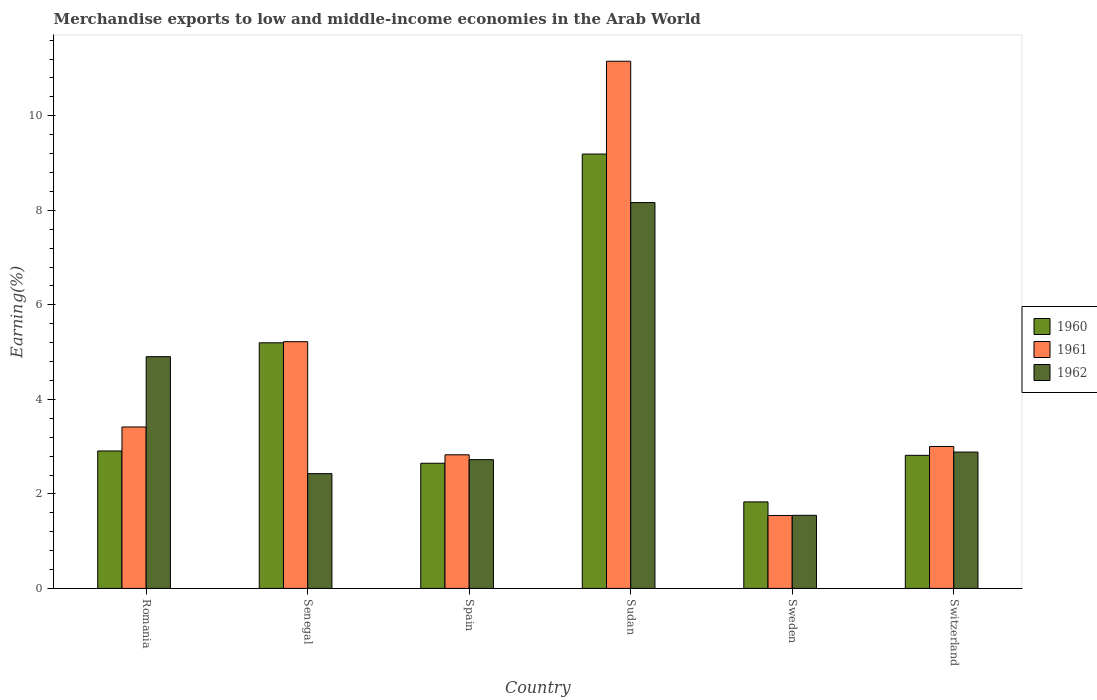Are the number of bars per tick equal to the number of legend labels?
Make the answer very short. Yes. Are the number of bars on each tick of the X-axis equal?
Your response must be concise. Yes. How many bars are there on the 3rd tick from the right?
Offer a terse response. 3. What is the label of the 6th group of bars from the left?
Provide a short and direct response. Switzerland. In how many cases, is the number of bars for a given country not equal to the number of legend labels?
Your answer should be compact. 0. What is the percentage of amount earned from merchandise exports in 1962 in Sudan?
Offer a terse response. 8.16. Across all countries, what is the maximum percentage of amount earned from merchandise exports in 1961?
Provide a short and direct response. 11.15. Across all countries, what is the minimum percentage of amount earned from merchandise exports in 1962?
Your answer should be compact. 1.55. In which country was the percentage of amount earned from merchandise exports in 1961 maximum?
Keep it short and to the point. Sudan. What is the total percentage of amount earned from merchandise exports in 1961 in the graph?
Your answer should be very brief. 27.17. What is the difference between the percentage of amount earned from merchandise exports in 1961 in Spain and that in Switzerland?
Offer a very short reply. -0.18. What is the difference between the percentage of amount earned from merchandise exports in 1962 in Sudan and the percentage of amount earned from merchandise exports in 1961 in Sweden?
Ensure brevity in your answer.  6.62. What is the average percentage of amount earned from merchandise exports in 1961 per country?
Offer a terse response. 4.53. What is the difference between the percentage of amount earned from merchandise exports of/in 1960 and percentage of amount earned from merchandise exports of/in 1962 in Sweden?
Give a very brief answer. 0.28. In how many countries, is the percentage of amount earned from merchandise exports in 1960 greater than 4.4 %?
Keep it short and to the point. 2. What is the ratio of the percentage of amount earned from merchandise exports in 1961 in Sweden to that in Switzerland?
Offer a terse response. 0.51. Is the percentage of amount earned from merchandise exports in 1961 in Senegal less than that in Sudan?
Give a very brief answer. Yes. What is the difference between the highest and the second highest percentage of amount earned from merchandise exports in 1961?
Your answer should be compact. -7.74. What is the difference between the highest and the lowest percentage of amount earned from merchandise exports in 1960?
Provide a succinct answer. 7.36. What does the 2nd bar from the left in Spain represents?
Offer a very short reply. 1961. How many bars are there?
Your answer should be compact. 18. How many countries are there in the graph?
Give a very brief answer. 6. What is the difference between two consecutive major ticks on the Y-axis?
Your answer should be very brief. 2. Does the graph contain any zero values?
Provide a succinct answer. No. Where does the legend appear in the graph?
Make the answer very short. Center right. What is the title of the graph?
Your answer should be compact. Merchandise exports to low and middle-income economies in the Arab World. What is the label or title of the X-axis?
Your answer should be very brief. Country. What is the label or title of the Y-axis?
Your response must be concise. Earning(%). What is the Earning(%) of 1960 in Romania?
Give a very brief answer. 2.91. What is the Earning(%) in 1961 in Romania?
Your answer should be compact. 3.42. What is the Earning(%) of 1962 in Romania?
Your response must be concise. 4.9. What is the Earning(%) of 1960 in Senegal?
Offer a terse response. 5.2. What is the Earning(%) of 1961 in Senegal?
Offer a very short reply. 5.22. What is the Earning(%) in 1962 in Senegal?
Give a very brief answer. 2.43. What is the Earning(%) in 1960 in Spain?
Ensure brevity in your answer.  2.65. What is the Earning(%) in 1961 in Spain?
Your answer should be compact. 2.83. What is the Earning(%) in 1962 in Spain?
Keep it short and to the point. 2.73. What is the Earning(%) in 1960 in Sudan?
Ensure brevity in your answer.  9.19. What is the Earning(%) in 1961 in Sudan?
Provide a succinct answer. 11.15. What is the Earning(%) of 1962 in Sudan?
Provide a succinct answer. 8.16. What is the Earning(%) in 1960 in Sweden?
Make the answer very short. 1.83. What is the Earning(%) in 1961 in Sweden?
Make the answer very short. 1.54. What is the Earning(%) in 1962 in Sweden?
Your response must be concise. 1.55. What is the Earning(%) in 1960 in Switzerland?
Give a very brief answer. 2.82. What is the Earning(%) in 1961 in Switzerland?
Your response must be concise. 3. What is the Earning(%) of 1962 in Switzerland?
Offer a terse response. 2.89. Across all countries, what is the maximum Earning(%) of 1960?
Offer a terse response. 9.19. Across all countries, what is the maximum Earning(%) in 1961?
Your response must be concise. 11.15. Across all countries, what is the maximum Earning(%) of 1962?
Make the answer very short. 8.16. Across all countries, what is the minimum Earning(%) of 1960?
Provide a short and direct response. 1.83. Across all countries, what is the minimum Earning(%) in 1961?
Your answer should be compact. 1.54. Across all countries, what is the minimum Earning(%) in 1962?
Your answer should be compact. 1.55. What is the total Earning(%) of 1960 in the graph?
Offer a very short reply. 24.59. What is the total Earning(%) of 1961 in the graph?
Your answer should be very brief. 27.17. What is the total Earning(%) of 1962 in the graph?
Keep it short and to the point. 22.66. What is the difference between the Earning(%) in 1960 in Romania and that in Senegal?
Your answer should be compact. -2.29. What is the difference between the Earning(%) in 1961 in Romania and that in Senegal?
Give a very brief answer. -1.8. What is the difference between the Earning(%) of 1962 in Romania and that in Senegal?
Ensure brevity in your answer.  2.47. What is the difference between the Earning(%) in 1960 in Romania and that in Spain?
Offer a terse response. 0.26. What is the difference between the Earning(%) in 1961 in Romania and that in Spain?
Give a very brief answer. 0.59. What is the difference between the Earning(%) of 1962 in Romania and that in Spain?
Offer a very short reply. 2.18. What is the difference between the Earning(%) in 1960 in Romania and that in Sudan?
Offer a terse response. -6.28. What is the difference between the Earning(%) of 1961 in Romania and that in Sudan?
Your answer should be very brief. -7.74. What is the difference between the Earning(%) of 1962 in Romania and that in Sudan?
Ensure brevity in your answer.  -3.26. What is the difference between the Earning(%) in 1960 in Romania and that in Sweden?
Provide a succinct answer. 1.08. What is the difference between the Earning(%) in 1961 in Romania and that in Sweden?
Keep it short and to the point. 1.87. What is the difference between the Earning(%) of 1962 in Romania and that in Sweden?
Your answer should be very brief. 3.36. What is the difference between the Earning(%) of 1960 in Romania and that in Switzerland?
Keep it short and to the point. 0.09. What is the difference between the Earning(%) in 1961 in Romania and that in Switzerland?
Provide a short and direct response. 0.41. What is the difference between the Earning(%) in 1962 in Romania and that in Switzerland?
Offer a very short reply. 2.02. What is the difference between the Earning(%) of 1960 in Senegal and that in Spain?
Keep it short and to the point. 2.55. What is the difference between the Earning(%) of 1961 in Senegal and that in Spain?
Keep it short and to the point. 2.39. What is the difference between the Earning(%) in 1962 in Senegal and that in Spain?
Offer a very short reply. -0.3. What is the difference between the Earning(%) in 1960 in Senegal and that in Sudan?
Provide a short and direct response. -3.99. What is the difference between the Earning(%) of 1961 in Senegal and that in Sudan?
Ensure brevity in your answer.  -5.93. What is the difference between the Earning(%) in 1962 in Senegal and that in Sudan?
Provide a short and direct response. -5.74. What is the difference between the Earning(%) of 1960 in Senegal and that in Sweden?
Your response must be concise. 3.37. What is the difference between the Earning(%) in 1961 in Senegal and that in Sweden?
Keep it short and to the point. 3.68. What is the difference between the Earning(%) of 1962 in Senegal and that in Sweden?
Your answer should be very brief. 0.88. What is the difference between the Earning(%) of 1960 in Senegal and that in Switzerland?
Ensure brevity in your answer.  2.38. What is the difference between the Earning(%) of 1961 in Senegal and that in Switzerland?
Make the answer very short. 2.22. What is the difference between the Earning(%) of 1962 in Senegal and that in Switzerland?
Ensure brevity in your answer.  -0.46. What is the difference between the Earning(%) in 1960 in Spain and that in Sudan?
Offer a very short reply. -6.54. What is the difference between the Earning(%) of 1961 in Spain and that in Sudan?
Make the answer very short. -8.33. What is the difference between the Earning(%) in 1962 in Spain and that in Sudan?
Offer a terse response. -5.44. What is the difference between the Earning(%) in 1960 in Spain and that in Sweden?
Offer a very short reply. 0.82. What is the difference between the Earning(%) in 1961 in Spain and that in Sweden?
Offer a very short reply. 1.28. What is the difference between the Earning(%) in 1962 in Spain and that in Sweden?
Offer a very short reply. 1.18. What is the difference between the Earning(%) in 1960 in Spain and that in Switzerland?
Ensure brevity in your answer.  -0.17. What is the difference between the Earning(%) of 1961 in Spain and that in Switzerland?
Offer a very short reply. -0.18. What is the difference between the Earning(%) in 1962 in Spain and that in Switzerland?
Keep it short and to the point. -0.16. What is the difference between the Earning(%) of 1960 in Sudan and that in Sweden?
Your answer should be compact. 7.36. What is the difference between the Earning(%) in 1961 in Sudan and that in Sweden?
Provide a short and direct response. 9.61. What is the difference between the Earning(%) in 1962 in Sudan and that in Sweden?
Offer a terse response. 6.62. What is the difference between the Earning(%) of 1960 in Sudan and that in Switzerland?
Keep it short and to the point. 6.37. What is the difference between the Earning(%) of 1961 in Sudan and that in Switzerland?
Provide a short and direct response. 8.15. What is the difference between the Earning(%) in 1962 in Sudan and that in Switzerland?
Offer a very short reply. 5.28. What is the difference between the Earning(%) of 1960 in Sweden and that in Switzerland?
Give a very brief answer. -0.99. What is the difference between the Earning(%) in 1961 in Sweden and that in Switzerland?
Keep it short and to the point. -1.46. What is the difference between the Earning(%) of 1962 in Sweden and that in Switzerland?
Keep it short and to the point. -1.34. What is the difference between the Earning(%) of 1960 in Romania and the Earning(%) of 1961 in Senegal?
Provide a succinct answer. -2.31. What is the difference between the Earning(%) of 1960 in Romania and the Earning(%) of 1962 in Senegal?
Your response must be concise. 0.48. What is the difference between the Earning(%) in 1961 in Romania and the Earning(%) in 1962 in Senegal?
Your response must be concise. 0.99. What is the difference between the Earning(%) in 1960 in Romania and the Earning(%) in 1961 in Spain?
Make the answer very short. 0.08. What is the difference between the Earning(%) of 1960 in Romania and the Earning(%) of 1962 in Spain?
Your answer should be compact. 0.18. What is the difference between the Earning(%) in 1961 in Romania and the Earning(%) in 1962 in Spain?
Keep it short and to the point. 0.69. What is the difference between the Earning(%) of 1960 in Romania and the Earning(%) of 1961 in Sudan?
Your response must be concise. -8.25. What is the difference between the Earning(%) in 1960 in Romania and the Earning(%) in 1962 in Sudan?
Make the answer very short. -5.26. What is the difference between the Earning(%) in 1961 in Romania and the Earning(%) in 1962 in Sudan?
Offer a very short reply. -4.75. What is the difference between the Earning(%) in 1960 in Romania and the Earning(%) in 1961 in Sweden?
Keep it short and to the point. 1.36. What is the difference between the Earning(%) in 1960 in Romania and the Earning(%) in 1962 in Sweden?
Your answer should be very brief. 1.36. What is the difference between the Earning(%) of 1961 in Romania and the Earning(%) of 1962 in Sweden?
Make the answer very short. 1.87. What is the difference between the Earning(%) in 1960 in Romania and the Earning(%) in 1961 in Switzerland?
Give a very brief answer. -0.09. What is the difference between the Earning(%) of 1960 in Romania and the Earning(%) of 1962 in Switzerland?
Your response must be concise. 0.02. What is the difference between the Earning(%) in 1961 in Romania and the Earning(%) in 1962 in Switzerland?
Your answer should be very brief. 0.53. What is the difference between the Earning(%) in 1960 in Senegal and the Earning(%) in 1961 in Spain?
Provide a succinct answer. 2.37. What is the difference between the Earning(%) in 1960 in Senegal and the Earning(%) in 1962 in Spain?
Make the answer very short. 2.47. What is the difference between the Earning(%) in 1961 in Senegal and the Earning(%) in 1962 in Spain?
Your response must be concise. 2.5. What is the difference between the Earning(%) of 1960 in Senegal and the Earning(%) of 1961 in Sudan?
Make the answer very short. -5.96. What is the difference between the Earning(%) in 1960 in Senegal and the Earning(%) in 1962 in Sudan?
Make the answer very short. -2.97. What is the difference between the Earning(%) of 1961 in Senegal and the Earning(%) of 1962 in Sudan?
Make the answer very short. -2.94. What is the difference between the Earning(%) of 1960 in Senegal and the Earning(%) of 1961 in Sweden?
Your response must be concise. 3.65. What is the difference between the Earning(%) of 1960 in Senegal and the Earning(%) of 1962 in Sweden?
Give a very brief answer. 3.65. What is the difference between the Earning(%) of 1961 in Senegal and the Earning(%) of 1962 in Sweden?
Offer a very short reply. 3.67. What is the difference between the Earning(%) of 1960 in Senegal and the Earning(%) of 1961 in Switzerland?
Your answer should be very brief. 2.19. What is the difference between the Earning(%) in 1960 in Senegal and the Earning(%) in 1962 in Switzerland?
Give a very brief answer. 2.31. What is the difference between the Earning(%) of 1961 in Senegal and the Earning(%) of 1962 in Switzerland?
Make the answer very short. 2.34. What is the difference between the Earning(%) of 1960 in Spain and the Earning(%) of 1961 in Sudan?
Your response must be concise. -8.51. What is the difference between the Earning(%) in 1960 in Spain and the Earning(%) in 1962 in Sudan?
Your response must be concise. -5.52. What is the difference between the Earning(%) of 1961 in Spain and the Earning(%) of 1962 in Sudan?
Make the answer very short. -5.34. What is the difference between the Earning(%) of 1960 in Spain and the Earning(%) of 1961 in Sweden?
Keep it short and to the point. 1.1. What is the difference between the Earning(%) of 1960 in Spain and the Earning(%) of 1962 in Sweden?
Ensure brevity in your answer.  1.1. What is the difference between the Earning(%) in 1961 in Spain and the Earning(%) in 1962 in Sweden?
Give a very brief answer. 1.28. What is the difference between the Earning(%) of 1960 in Spain and the Earning(%) of 1961 in Switzerland?
Your answer should be compact. -0.35. What is the difference between the Earning(%) in 1960 in Spain and the Earning(%) in 1962 in Switzerland?
Keep it short and to the point. -0.24. What is the difference between the Earning(%) in 1961 in Spain and the Earning(%) in 1962 in Switzerland?
Provide a succinct answer. -0.06. What is the difference between the Earning(%) of 1960 in Sudan and the Earning(%) of 1961 in Sweden?
Your response must be concise. 7.65. What is the difference between the Earning(%) of 1960 in Sudan and the Earning(%) of 1962 in Sweden?
Offer a very short reply. 7.64. What is the difference between the Earning(%) of 1961 in Sudan and the Earning(%) of 1962 in Sweden?
Ensure brevity in your answer.  9.61. What is the difference between the Earning(%) of 1960 in Sudan and the Earning(%) of 1961 in Switzerland?
Your response must be concise. 6.19. What is the difference between the Earning(%) of 1960 in Sudan and the Earning(%) of 1962 in Switzerland?
Make the answer very short. 6.31. What is the difference between the Earning(%) in 1961 in Sudan and the Earning(%) in 1962 in Switzerland?
Offer a very short reply. 8.27. What is the difference between the Earning(%) in 1960 in Sweden and the Earning(%) in 1961 in Switzerland?
Provide a short and direct response. -1.17. What is the difference between the Earning(%) of 1960 in Sweden and the Earning(%) of 1962 in Switzerland?
Keep it short and to the point. -1.05. What is the difference between the Earning(%) of 1961 in Sweden and the Earning(%) of 1962 in Switzerland?
Your answer should be very brief. -1.34. What is the average Earning(%) in 1960 per country?
Give a very brief answer. 4.1. What is the average Earning(%) in 1961 per country?
Give a very brief answer. 4.53. What is the average Earning(%) in 1962 per country?
Your response must be concise. 3.78. What is the difference between the Earning(%) in 1960 and Earning(%) in 1961 in Romania?
Ensure brevity in your answer.  -0.51. What is the difference between the Earning(%) in 1960 and Earning(%) in 1962 in Romania?
Provide a short and direct response. -2. What is the difference between the Earning(%) in 1961 and Earning(%) in 1962 in Romania?
Your answer should be compact. -1.49. What is the difference between the Earning(%) in 1960 and Earning(%) in 1961 in Senegal?
Make the answer very short. -0.02. What is the difference between the Earning(%) of 1960 and Earning(%) of 1962 in Senegal?
Make the answer very short. 2.77. What is the difference between the Earning(%) of 1961 and Earning(%) of 1962 in Senegal?
Keep it short and to the point. 2.79. What is the difference between the Earning(%) in 1960 and Earning(%) in 1961 in Spain?
Offer a very short reply. -0.18. What is the difference between the Earning(%) in 1960 and Earning(%) in 1962 in Spain?
Ensure brevity in your answer.  -0.08. What is the difference between the Earning(%) of 1961 and Earning(%) of 1962 in Spain?
Your answer should be compact. 0.1. What is the difference between the Earning(%) of 1960 and Earning(%) of 1961 in Sudan?
Your answer should be very brief. -1.96. What is the difference between the Earning(%) of 1960 and Earning(%) of 1962 in Sudan?
Ensure brevity in your answer.  1.03. What is the difference between the Earning(%) of 1961 and Earning(%) of 1962 in Sudan?
Give a very brief answer. 2.99. What is the difference between the Earning(%) of 1960 and Earning(%) of 1961 in Sweden?
Offer a terse response. 0.29. What is the difference between the Earning(%) in 1960 and Earning(%) in 1962 in Sweden?
Offer a terse response. 0.28. What is the difference between the Earning(%) of 1961 and Earning(%) of 1962 in Sweden?
Offer a very short reply. -0. What is the difference between the Earning(%) of 1960 and Earning(%) of 1961 in Switzerland?
Offer a very short reply. -0.19. What is the difference between the Earning(%) of 1960 and Earning(%) of 1962 in Switzerland?
Make the answer very short. -0.07. What is the difference between the Earning(%) of 1961 and Earning(%) of 1962 in Switzerland?
Make the answer very short. 0.12. What is the ratio of the Earning(%) in 1960 in Romania to that in Senegal?
Your answer should be compact. 0.56. What is the ratio of the Earning(%) in 1961 in Romania to that in Senegal?
Offer a terse response. 0.65. What is the ratio of the Earning(%) in 1962 in Romania to that in Senegal?
Ensure brevity in your answer.  2.02. What is the ratio of the Earning(%) of 1960 in Romania to that in Spain?
Provide a short and direct response. 1.1. What is the ratio of the Earning(%) of 1961 in Romania to that in Spain?
Make the answer very short. 1.21. What is the ratio of the Earning(%) in 1962 in Romania to that in Spain?
Give a very brief answer. 1.8. What is the ratio of the Earning(%) of 1960 in Romania to that in Sudan?
Make the answer very short. 0.32. What is the ratio of the Earning(%) of 1961 in Romania to that in Sudan?
Your answer should be compact. 0.31. What is the ratio of the Earning(%) in 1962 in Romania to that in Sudan?
Make the answer very short. 0.6. What is the ratio of the Earning(%) of 1960 in Romania to that in Sweden?
Make the answer very short. 1.59. What is the ratio of the Earning(%) in 1961 in Romania to that in Sweden?
Keep it short and to the point. 2.21. What is the ratio of the Earning(%) of 1962 in Romania to that in Sweden?
Your answer should be very brief. 3.17. What is the ratio of the Earning(%) in 1960 in Romania to that in Switzerland?
Make the answer very short. 1.03. What is the ratio of the Earning(%) of 1961 in Romania to that in Switzerland?
Your answer should be very brief. 1.14. What is the ratio of the Earning(%) in 1962 in Romania to that in Switzerland?
Your response must be concise. 1.7. What is the ratio of the Earning(%) of 1960 in Senegal to that in Spain?
Give a very brief answer. 1.96. What is the ratio of the Earning(%) in 1961 in Senegal to that in Spain?
Offer a terse response. 1.85. What is the ratio of the Earning(%) of 1962 in Senegal to that in Spain?
Make the answer very short. 0.89. What is the ratio of the Earning(%) in 1960 in Senegal to that in Sudan?
Your answer should be compact. 0.57. What is the ratio of the Earning(%) of 1961 in Senegal to that in Sudan?
Your answer should be compact. 0.47. What is the ratio of the Earning(%) of 1962 in Senegal to that in Sudan?
Ensure brevity in your answer.  0.3. What is the ratio of the Earning(%) in 1960 in Senegal to that in Sweden?
Your response must be concise. 2.84. What is the ratio of the Earning(%) in 1961 in Senegal to that in Sweden?
Offer a very short reply. 3.38. What is the ratio of the Earning(%) of 1962 in Senegal to that in Sweden?
Provide a succinct answer. 1.57. What is the ratio of the Earning(%) of 1960 in Senegal to that in Switzerland?
Make the answer very short. 1.85. What is the ratio of the Earning(%) in 1961 in Senegal to that in Switzerland?
Ensure brevity in your answer.  1.74. What is the ratio of the Earning(%) in 1962 in Senegal to that in Switzerland?
Make the answer very short. 0.84. What is the ratio of the Earning(%) in 1960 in Spain to that in Sudan?
Make the answer very short. 0.29. What is the ratio of the Earning(%) in 1961 in Spain to that in Sudan?
Your response must be concise. 0.25. What is the ratio of the Earning(%) of 1962 in Spain to that in Sudan?
Keep it short and to the point. 0.33. What is the ratio of the Earning(%) in 1960 in Spain to that in Sweden?
Make the answer very short. 1.45. What is the ratio of the Earning(%) of 1961 in Spain to that in Sweden?
Your answer should be compact. 1.83. What is the ratio of the Earning(%) of 1962 in Spain to that in Sweden?
Ensure brevity in your answer.  1.76. What is the ratio of the Earning(%) of 1960 in Spain to that in Switzerland?
Give a very brief answer. 0.94. What is the ratio of the Earning(%) of 1961 in Spain to that in Switzerland?
Ensure brevity in your answer.  0.94. What is the ratio of the Earning(%) of 1962 in Spain to that in Switzerland?
Your response must be concise. 0.94. What is the ratio of the Earning(%) of 1960 in Sudan to that in Sweden?
Offer a terse response. 5.02. What is the ratio of the Earning(%) of 1961 in Sudan to that in Sweden?
Provide a succinct answer. 7.22. What is the ratio of the Earning(%) of 1962 in Sudan to that in Sweden?
Ensure brevity in your answer.  5.28. What is the ratio of the Earning(%) in 1960 in Sudan to that in Switzerland?
Your answer should be very brief. 3.26. What is the ratio of the Earning(%) of 1961 in Sudan to that in Switzerland?
Offer a very short reply. 3.71. What is the ratio of the Earning(%) in 1962 in Sudan to that in Switzerland?
Your answer should be compact. 2.83. What is the ratio of the Earning(%) of 1960 in Sweden to that in Switzerland?
Give a very brief answer. 0.65. What is the ratio of the Earning(%) in 1961 in Sweden to that in Switzerland?
Provide a short and direct response. 0.51. What is the ratio of the Earning(%) in 1962 in Sweden to that in Switzerland?
Make the answer very short. 0.54. What is the difference between the highest and the second highest Earning(%) of 1960?
Make the answer very short. 3.99. What is the difference between the highest and the second highest Earning(%) in 1961?
Give a very brief answer. 5.93. What is the difference between the highest and the second highest Earning(%) of 1962?
Provide a succinct answer. 3.26. What is the difference between the highest and the lowest Earning(%) of 1960?
Offer a terse response. 7.36. What is the difference between the highest and the lowest Earning(%) in 1961?
Provide a succinct answer. 9.61. What is the difference between the highest and the lowest Earning(%) in 1962?
Offer a terse response. 6.62. 